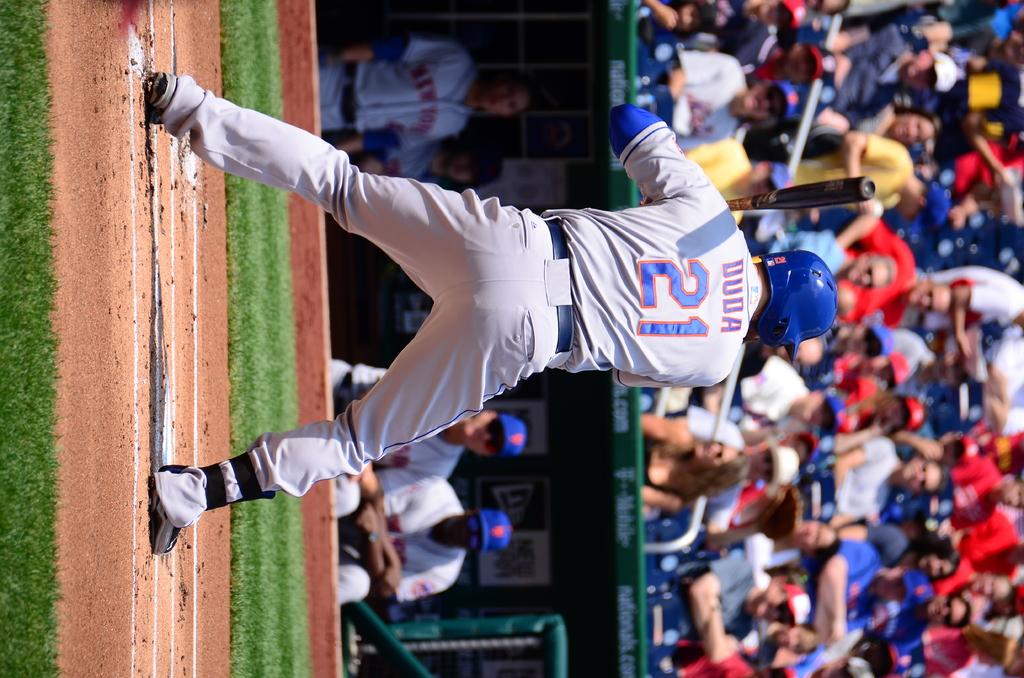<image>
Present a compact description of the photo's key features. A baseball player with the name Duda and the number 12 on the back of his jersey is batting. 